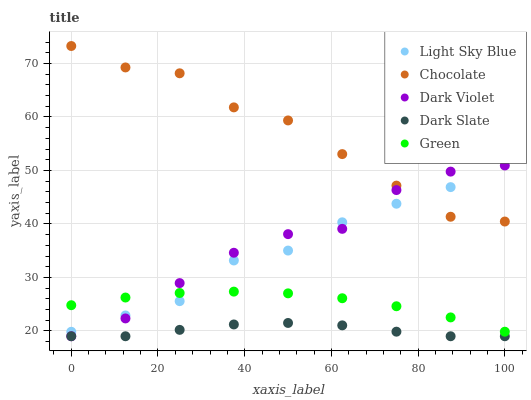Does Dark Slate have the minimum area under the curve?
Answer yes or no. Yes. Does Chocolate have the maximum area under the curve?
Answer yes or no. Yes. Does Light Sky Blue have the minimum area under the curve?
Answer yes or no. No. Does Light Sky Blue have the maximum area under the curve?
Answer yes or no. No. Is Green the smoothest?
Answer yes or no. Yes. Is Chocolate the roughest?
Answer yes or no. Yes. Is Light Sky Blue the smoothest?
Answer yes or no. No. Is Light Sky Blue the roughest?
Answer yes or no. No. Does Dark Slate have the lowest value?
Answer yes or no. Yes. Does Light Sky Blue have the lowest value?
Answer yes or no. No. Does Chocolate have the highest value?
Answer yes or no. Yes. Does Light Sky Blue have the highest value?
Answer yes or no. No. Is Green less than Chocolate?
Answer yes or no. Yes. Is Chocolate greater than Green?
Answer yes or no. Yes. Does Chocolate intersect Light Sky Blue?
Answer yes or no. Yes. Is Chocolate less than Light Sky Blue?
Answer yes or no. No. Is Chocolate greater than Light Sky Blue?
Answer yes or no. No. Does Green intersect Chocolate?
Answer yes or no. No. 